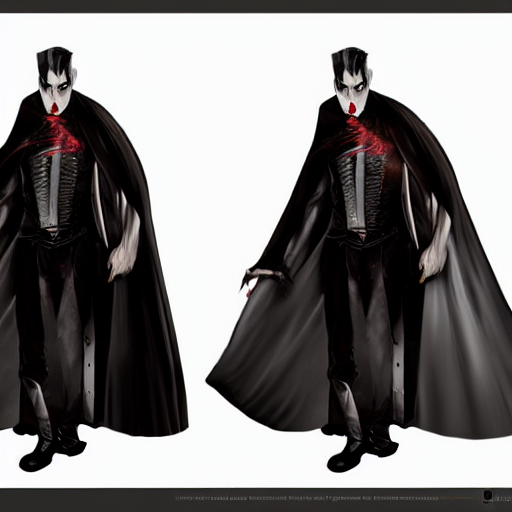Could you tell me more about the color palette used in this image? Certainly! The color palette of the image is quite limited yet striking, focusing heavily on contrasting hues of black and white, which emphasize the dramatic flair of the character’s appearance. The deep blacks in the character’s attire provide a stark contrast to the pale complexion of the skin, while the vibrant red accent around the neckline adds a bold touch of color that may symbolize power or menace. The overall palette contributes to a feeling of elegance intertwined with an air of danger. 